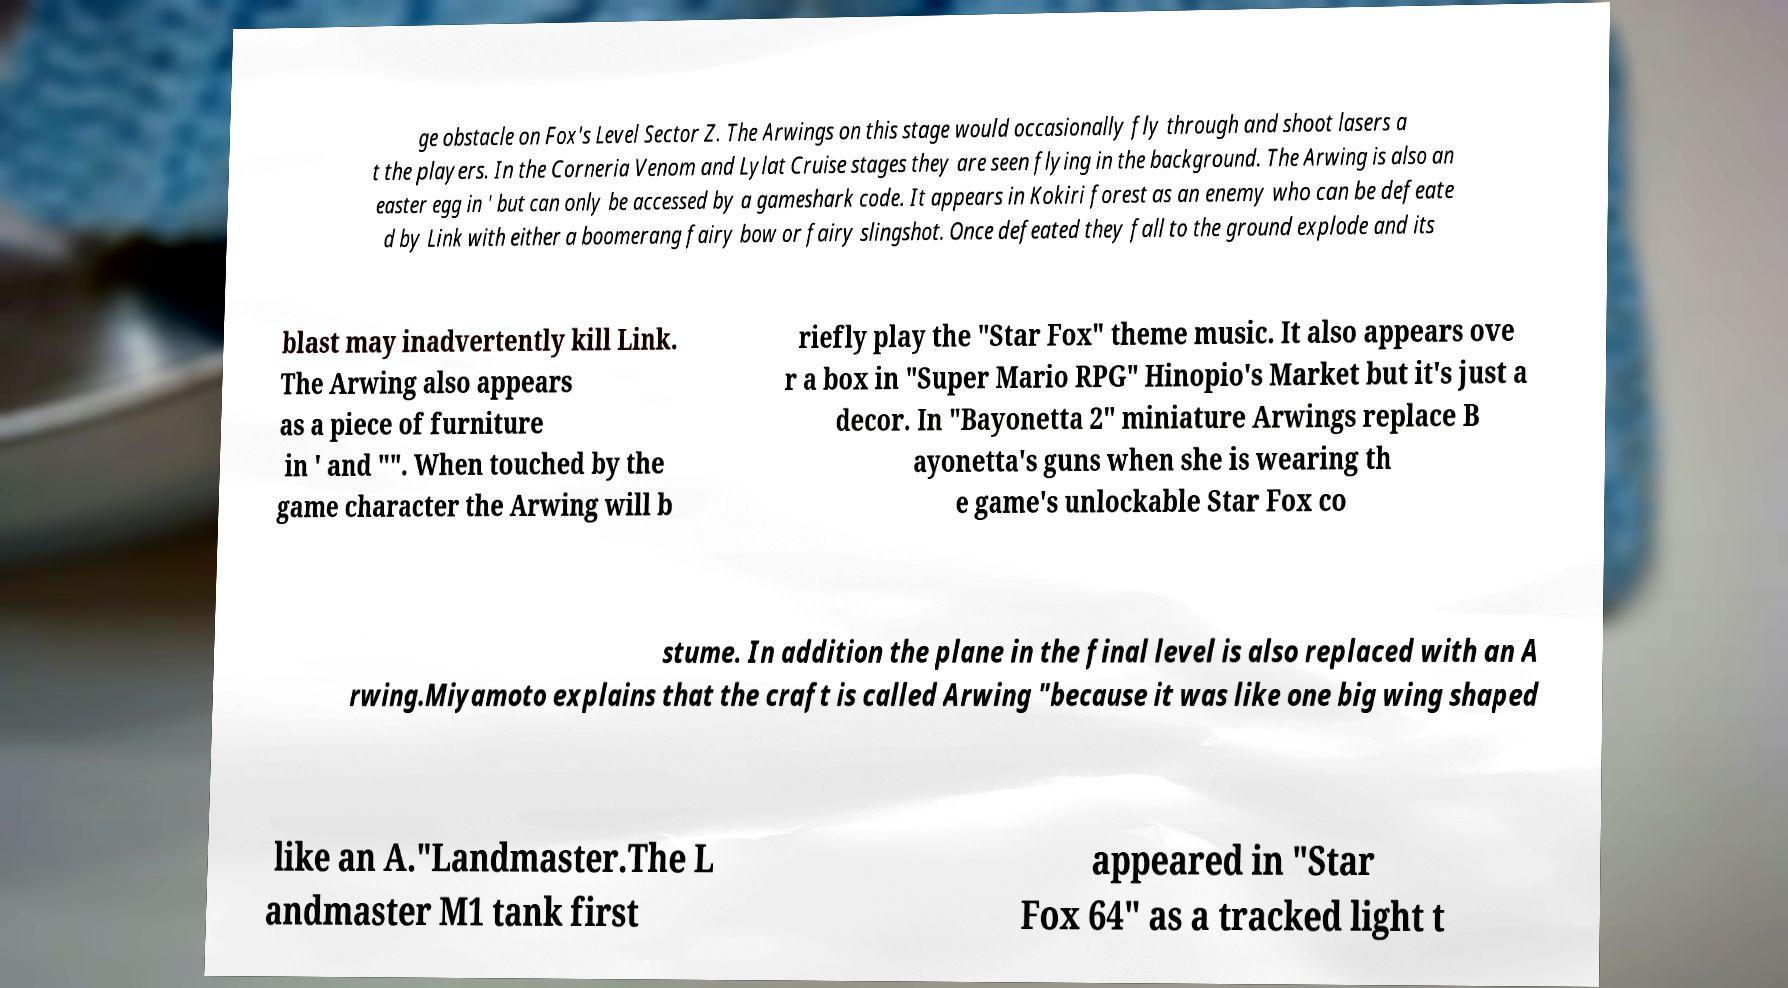Could you assist in decoding the text presented in this image and type it out clearly? ge obstacle on Fox's Level Sector Z. The Arwings on this stage would occasionally fly through and shoot lasers a t the players. In the Corneria Venom and Lylat Cruise stages they are seen flying in the background. The Arwing is also an easter egg in ' but can only be accessed by a gameshark code. It appears in Kokiri forest as an enemy who can be defeate d by Link with either a boomerang fairy bow or fairy slingshot. Once defeated they fall to the ground explode and its blast may inadvertently kill Link. The Arwing also appears as a piece of furniture in ' and "". When touched by the game character the Arwing will b riefly play the "Star Fox" theme music. It also appears ove r a box in "Super Mario RPG" Hinopio's Market but it's just a decor. In "Bayonetta 2" miniature Arwings replace B ayonetta's guns when she is wearing th e game's unlockable Star Fox co stume. In addition the plane in the final level is also replaced with an A rwing.Miyamoto explains that the craft is called Arwing "because it was like one big wing shaped like an A."Landmaster.The L andmaster M1 tank first appeared in "Star Fox 64" as a tracked light t 